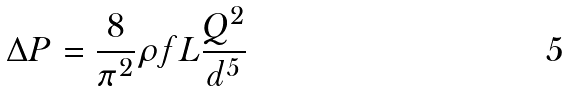<formula> <loc_0><loc_0><loc_500><loc_500>\Delta P = \frac { 8 } { \pi ^ { 2 } } \rho f L \frac { Q ^ { 2 } } { d ^ { 5 } }</formula> 